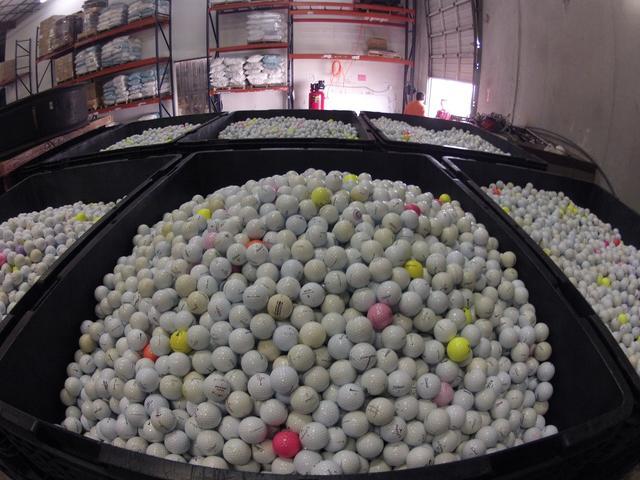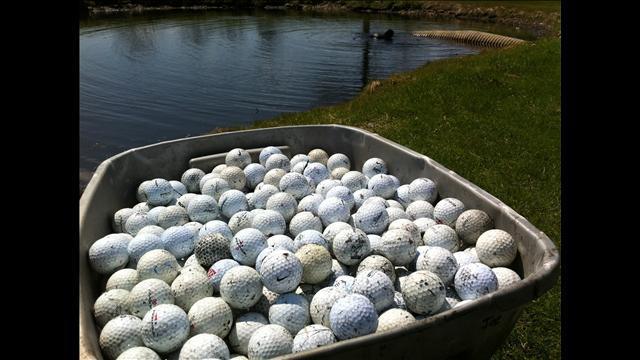The first image is the image on the left, the second image is the image on the right. Examine the images to the left and right. Is the description "Some of the balls are colorful." accurate? Answer yes or no. Yes. 